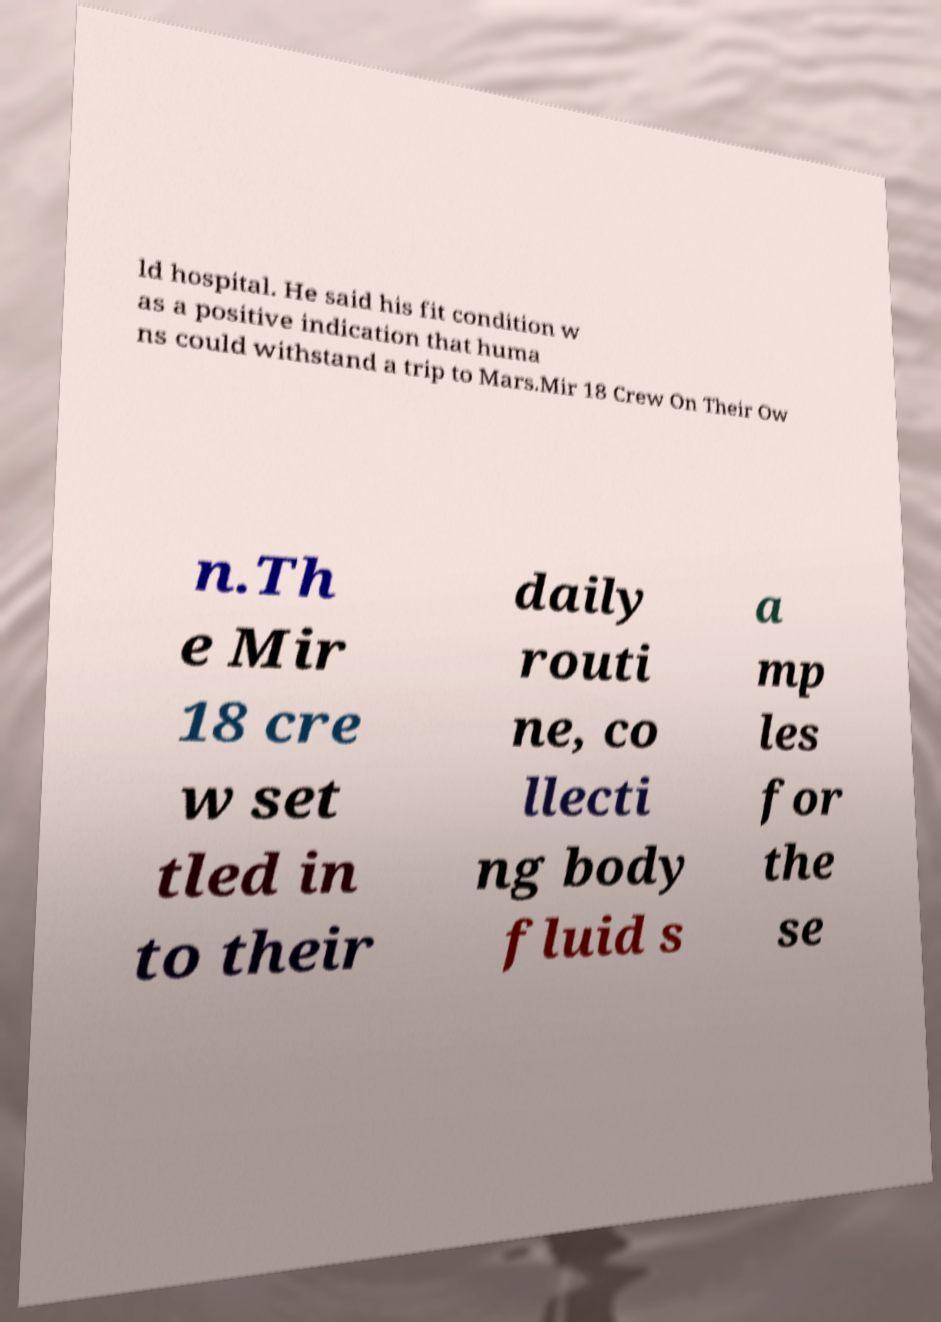What messages or text are displayed in this image? I need them in a readable, typed format. ld hospital. He said his fit condition w as a positive indication that huma ns could withstand a trip to Mars.Mir 18 Crew On Their Ow n.Th e Mir 18 cre w set tled in to their daily routi ne, co llecti ng body fluid s a mp les for the se 